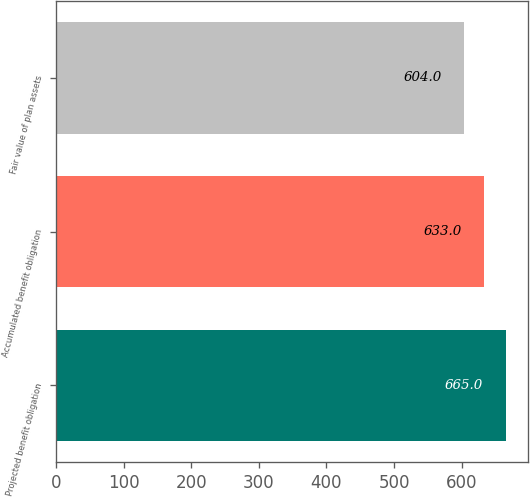<chart> <loc_0><loc_0><loc_500><loc_500><bar_chart><fcel>Projected benefit obligation<fcel>Accumulated benefit obligation<fcel>Fair value of plan assets<nl><fcel>665<fcel>633<fcel>604<nl></chart> 